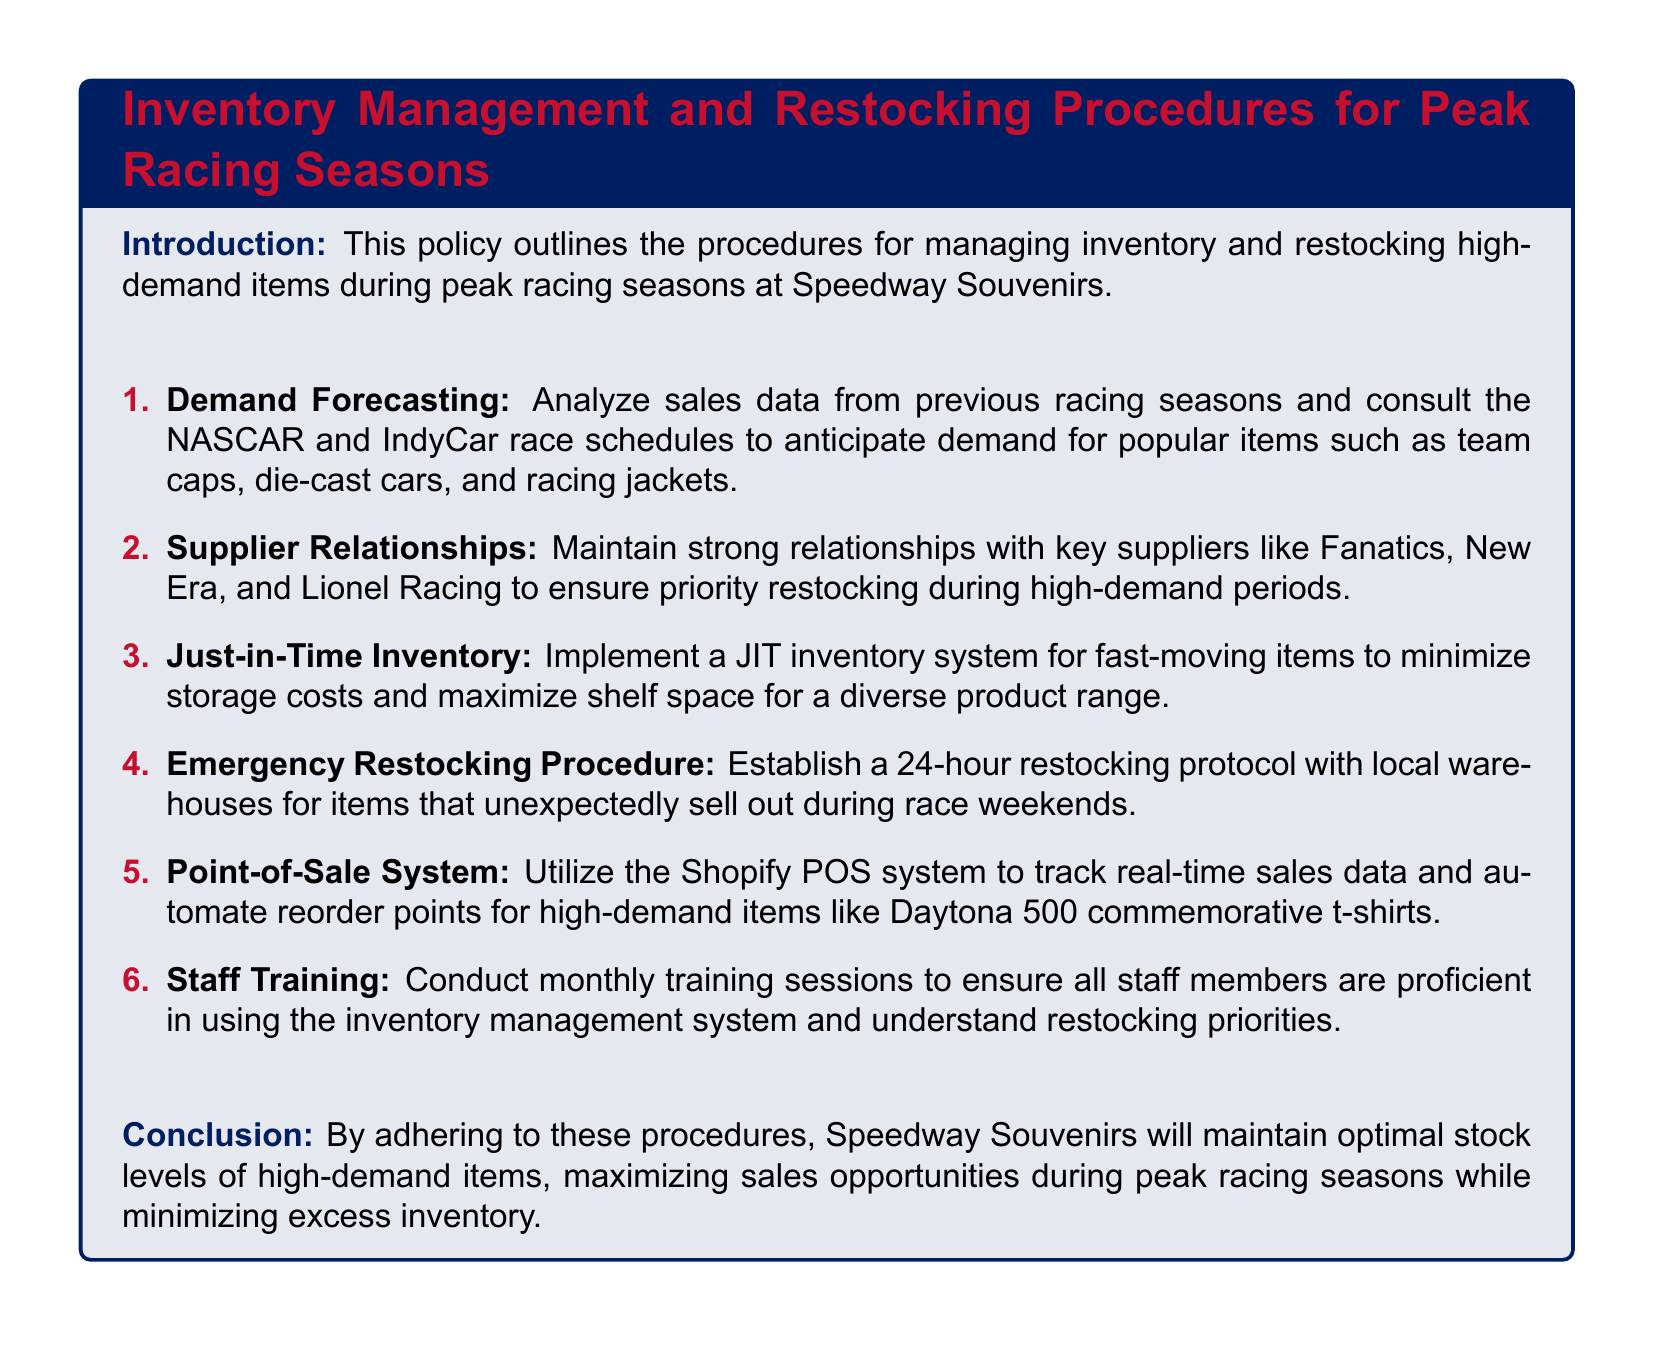What is the main focus of the policy document? The document outlines procedures for managing inventory and restocking high-demand items during peak racing seasons.
Answer: Inventory management and restocking procedures Who are mentioned as key suppliers in the document? The document lists key suppliers to maintain relationships with, specifically mentioning three names.
Answer: Fanatics, New Era, and Lionel Racing What inventory system is implemented for fast-moving items? The document discusses an inventory approach aimed at reducing storage costs, highlighting a specific type of system.
Answer: Just-in-Time (JIT) inventory What is the 24-hour restocking protocol designed for? The document specifies a response mechanism for items that sell out unexpectedly during specific event periods.
Answer: Emergency restocking Which system is utilized to track real-time sales data? The document identifies a particular system used for tracking and automating reorder points for high-demand items.
Answer: Shopify POS system How often are staff training sessions conducted? The document specifies the frequency of training sessions to ensure staff are proficient in inventory management.
Answer: Monthly What type of items does demand forecasting focus on? The document mentions specific categories of merchandise that are anticipated to have increased sales during peak times.
Answer: Team caps, die-cast cars, and racing jackets What is the purpose of conducting monthly training sessions? The document mentions a specific development objective for staff regarding their understanding of procedures.
Answer: To ensure proficiency in the inventory management system 